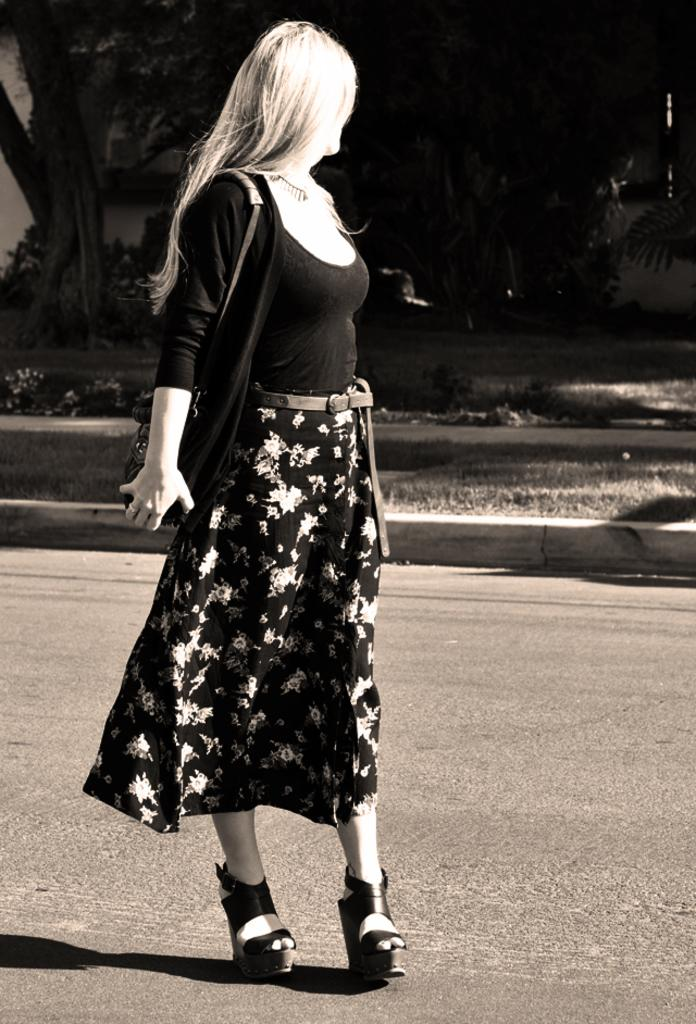Who is the main subject in the image? There is a woman in the image. What is the woman doing in the image? The woman is walking on the road. What is the woman carrying in the image? The woman is carrying a bag. What can be seen in the background of the image? There is grass, plants, and a tree in the background of the image. What type of dinner is the woman preparing in the image? There is no indication in the image that the woman is preparing dinner, as she is walking on the road and carrying a bag. 